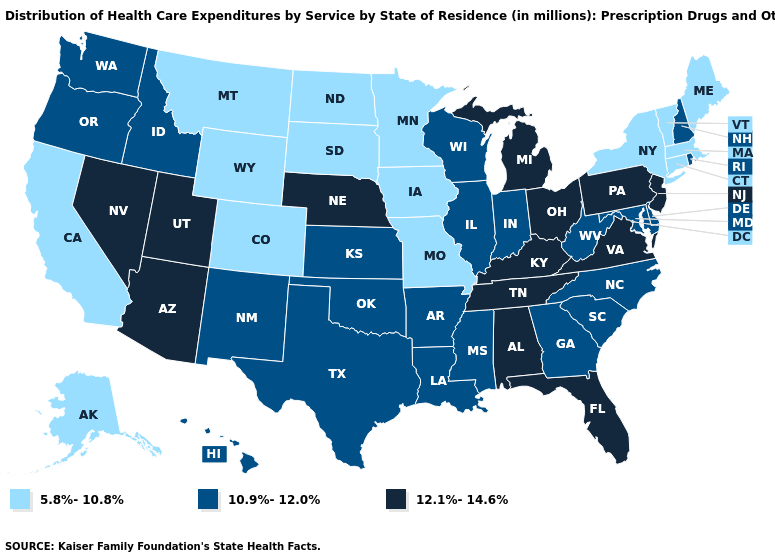What is the highest value in the USA?
Quick response, please. 12.1%-14.6%. Does the first symbol in the legend represent the smallest category?
Write a very short answer. Yes. What is the highest value in states that border Virginia?
Answer briefly. 12.1%-14.6%. Does Utah have the highest value in the USA?
Give a very brief answer. Yes. Which states have the lowest value in the USA?
Concise answer only. Alaska, California, Colorado, Connecticut, Iowa, Maine, Massachusetts, Minnesota, Missouri, Montana, New York, North Dakota, South Dakota, Vermont, Wyoming. Is the legend a continuous bar?
Give a very brief answer. No. Name the states that have a value in the range 10.9%-12.0%?
Answer briefly. Arkansas, Delaware, Georgia, Hawaii, Idaho, Illinois, Indiana, Kansas, Louisiana, Maryland, Mississippi, New Hampshire, New Mexico, North Carolina, Oklahoma, Oregon, Rhode Island, South Carolina, Texas, Washington, West Virginia, Wisconsin. What is the value of Wisconsin?
Be succinct. 10.9%-12.0%. What is the value of Utah?
Concise answer only. 12.1%-14.6%. Among the states that border Utah , which have the highest value?
Write a very short answer. Arizona, Nevada. Does Idaho have the lowest value in the USA?
Answer briefly. No. Does the map have missing data?
Write a very short answer. No. Does Texas have the same value as Rhode Island?
Give a very brief answer. Yes. Which states have the lowest value in the West?
Give a very brief answer. Alaska, California, Colorado, Montana, Wyoming. Which states hav the highest value in the MidWest?
Write a very short answer. Michigan, Nebraska, Ohio. 